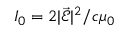Convert formula to latex. <formula><loc_0><loc_0><loc_500><loc_500>I _ { 0 } = 2 | \vec { \mathcal { E } } | ^ { 2 } / c \mu _ { 0 }</formula> 